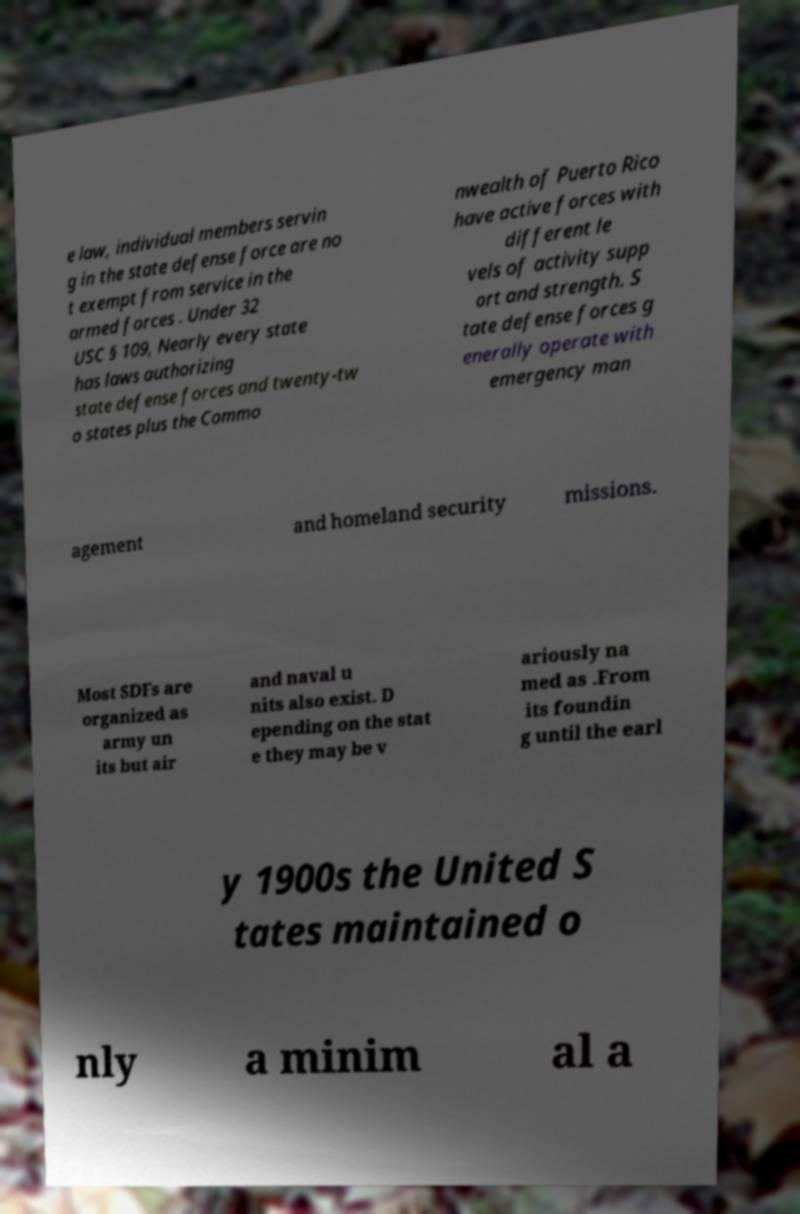Could you assist in decoding the text presented in this image and type it out clearly? e law, individual members servin g in the state defense force are no t exempt from service in the armed forces . Under 32 USC § 109, Nearly every state has laws authorizing state defense forces and twenty-tw o states plus the Commo nwealth of Puerto Rico have active forces with different le vels of activity supp ort and strength. S tate defense forces g enerally operate with emergency man agement and homeland security missions. Most SDFs are organized as army un its but air and naval u nits also exist. D epending on the stat e they may be v ariously na med as .From its foundin g until the earl y 1900s the United S tates maintained o nly a minim al a 